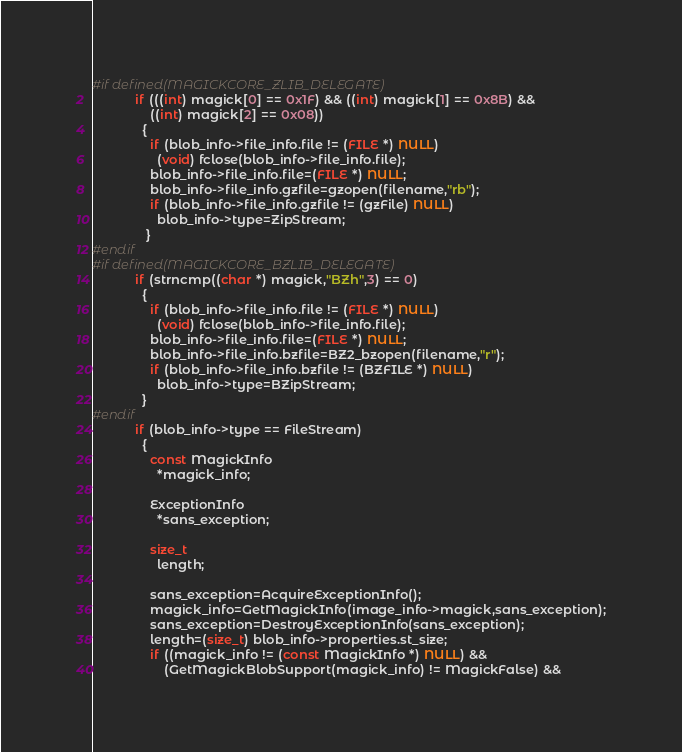<code> <loc_0><loc_0><loc_500><loc_500><_C_>#if defined(MAGICKCORE_ZLIB_DELEGATE)
            if (((int) magick[0] == 0x1F) && ((int) magick[1] == 0x8B) &&
                ((int) magick[2] == 0x08))
              {
                if (blob_info->file_info.file != (FILE *) NULL)
                  (void) fclose(blob_info->file_info.file);
                blob_info->file_info.file=(FILE *) NULL;
                blob_info->file_info.gzfile=gzopen(filename,"rb");
                if (blob_info->file_info.gzfile != (gzFile) NULL)
                  blob_info->type=ZipStream;
               }
#endif
#if defined(MAGICKCORE_BZLIB_DELEGATE)
            if (strncmp((char *) magick,"BZh",3) == 0)
              {
                if (blob_info->file_info.file != (FILE *) NULL)
                  (void) fclose(blob_info->file_info.file);
                blob_info->file_info.file=(FILE *) NULL;
                blob_info->file_info.bzfile=BZ2_bzopen(filename,"r");
                if (blob_info->file_info.bzfile != (BZFILE *) NULL)
                  blob_info->type=BZipStream;
              }
#endif
            if (blob_info->type == FileStream)
              {
                const MagickInfo
                  *magick_info;

                ExceptionInfo
                  *sans_exception;

                size_t
                  length;

                sans_exception=AcquireExceptionInfo();
                magick_info=GetMagickInfo(image_info->magick,sans_exception);
                sans_exception=DestroyExceptionInfo(sans_exception);
                length=(size_t) blob_info->properties.st_size;
                if ((magick_info != (const MagickInfo *) NULL) &&
                    (GetMagickBlobSupport(magick_info) != MagickFalse) &&</code> 